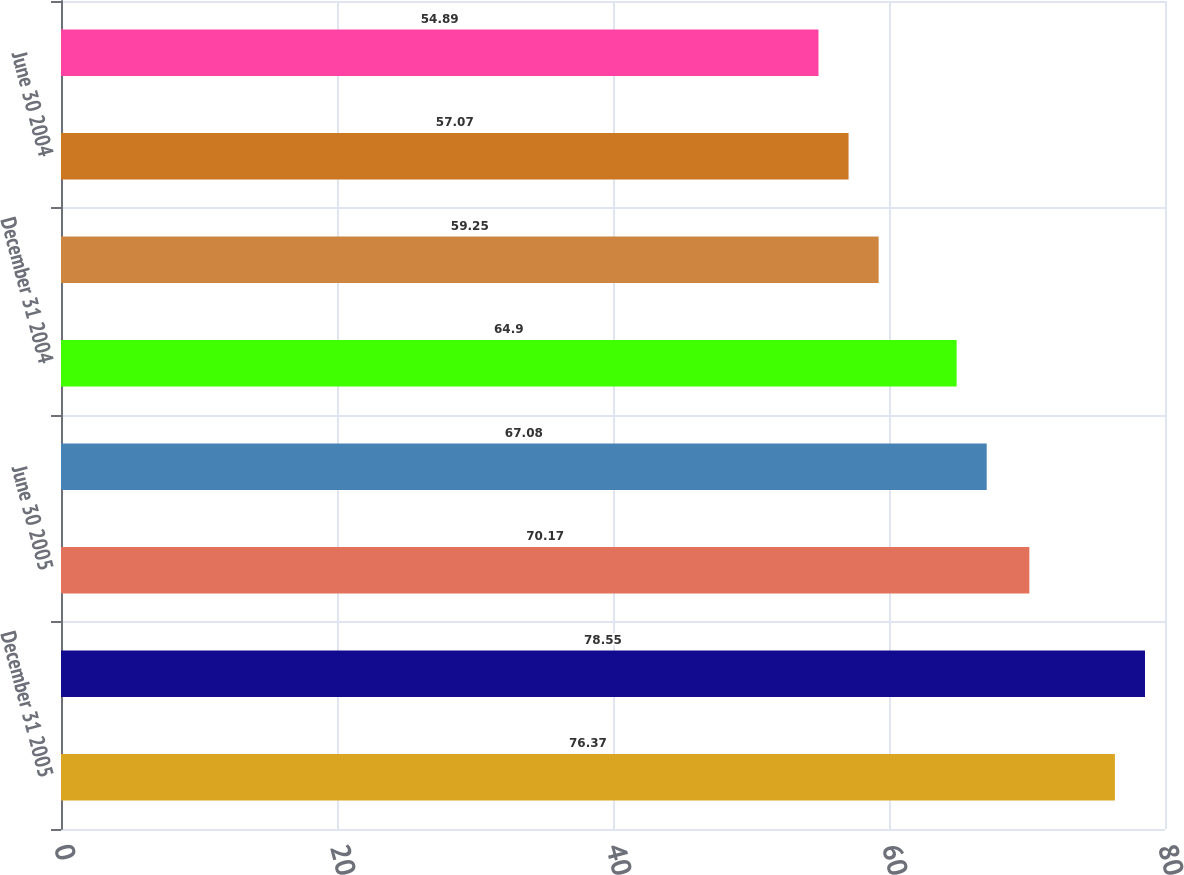Convert chart to OTSL. <chart><loc_0><loc_0><loc_500><loc_500><bar_chart><fcel>December 31 2005<fcel>September 30 2005<fcel>June 30 2005<fcel>March 31 2005<fcel>December 31 2004<fcel>September 30 2004<fcel>June 30 2004<fcel>March 31 2004<nl><fcel>76.37<fcel>78.55<fcel>70.17<fcel>67.08<fcel>64.9<fcel>59.25<fcel>57.07<fcel>54.89<nl></chart> 